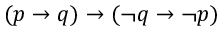<formula> <loc_0><loc_0><loc_500><loc_500>( p \to q ) \to ( \neg q \to \neg p )</formula> 